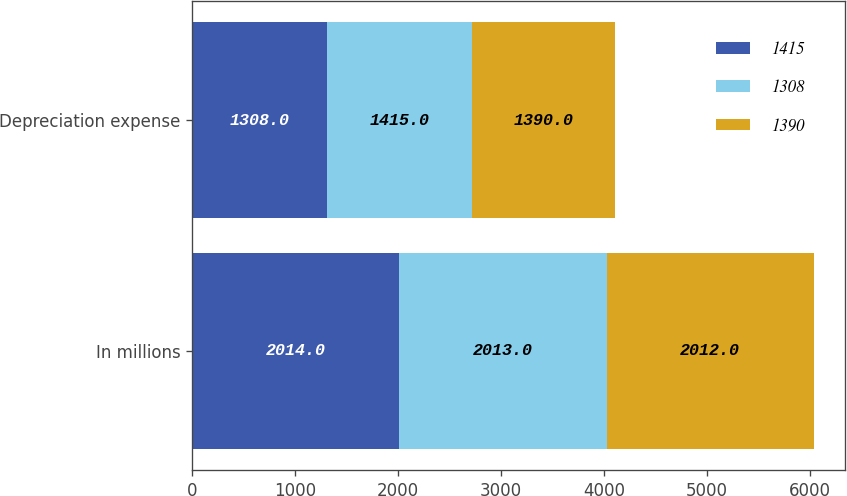Convert chart to OTSL. <chart><loc_0><loc_0><loc_500><loc_500><stacked_bar_chart><ecel><fcel>In millions<fcel>Depreciation expense<nl><fcel>1415<fcel>2014<fcel>1308<nl><fcel>1308<fcel>2013<fcel>1415<nl><fcel>1390<fcel>2012<fcel>1390<nl></chart> 